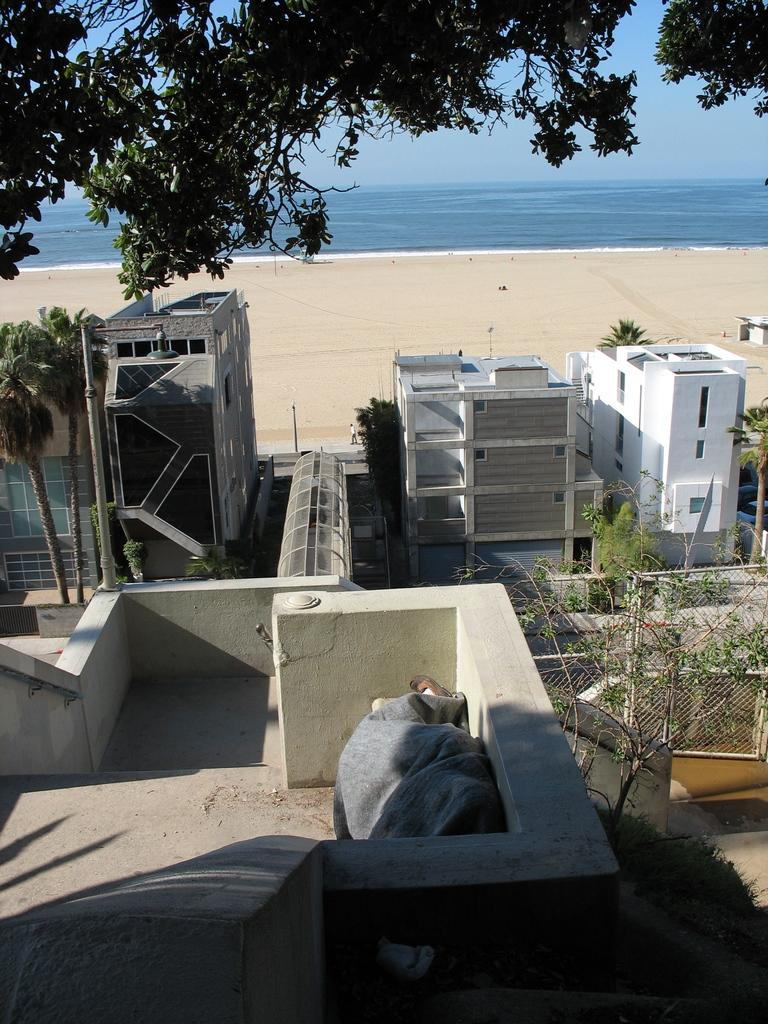What type of structures can be seen in the image? There are buildings in the image. What feature is visible on the buildings? There are windows visible in the image. What type of vegetation is present in the image? There are trees in the image. What type of barrier can be seen in the image? There is fencing in the image. What vertical structures are present in the image? There are poles in the image. What natural element is visible in the image? There is water visible in the image. What is the color of the sky in the image? The sky is blue in color. What type of thrill can be experienced by the buildings in the image? There is no indication of any thrill being experienced by the buildings in the image. What is the aftermath of the water in the image? There is no aftermath associated with the water in the image; it is simply visible. 